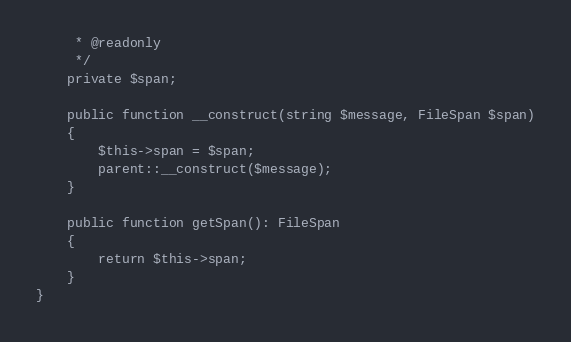Convert code to text. <code><loc_0><loc_0><loc_500><loc_500><_PHP_>     * @readonly
     */
    private $span;

    public function __construct(string $message, FileSpan $span)
    {
        $this->span = $span;
        parent::__construct($message);
    }

    public function getSpan(): FileSpan
    {
        return $this->span;
    }
}
</code> 